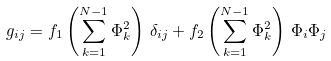Convert formula to latex. <formula><loc_0><loc_0><loc_500><loc_500>g _ { i j } = f _ { 1 } \left ( \sum _ { k = 1 } ^ { N - 1 } \Phi _ { k } ^ { 2 } \right ) \, \delta _ { i j } + f _ { 2 } \left ( \sum _ { k = 1 } ^ { N - 1 } \Phi _ { k } ^ { 2 } \right ) \, \Phi _ { i } \Phi _ { j }</formula> 